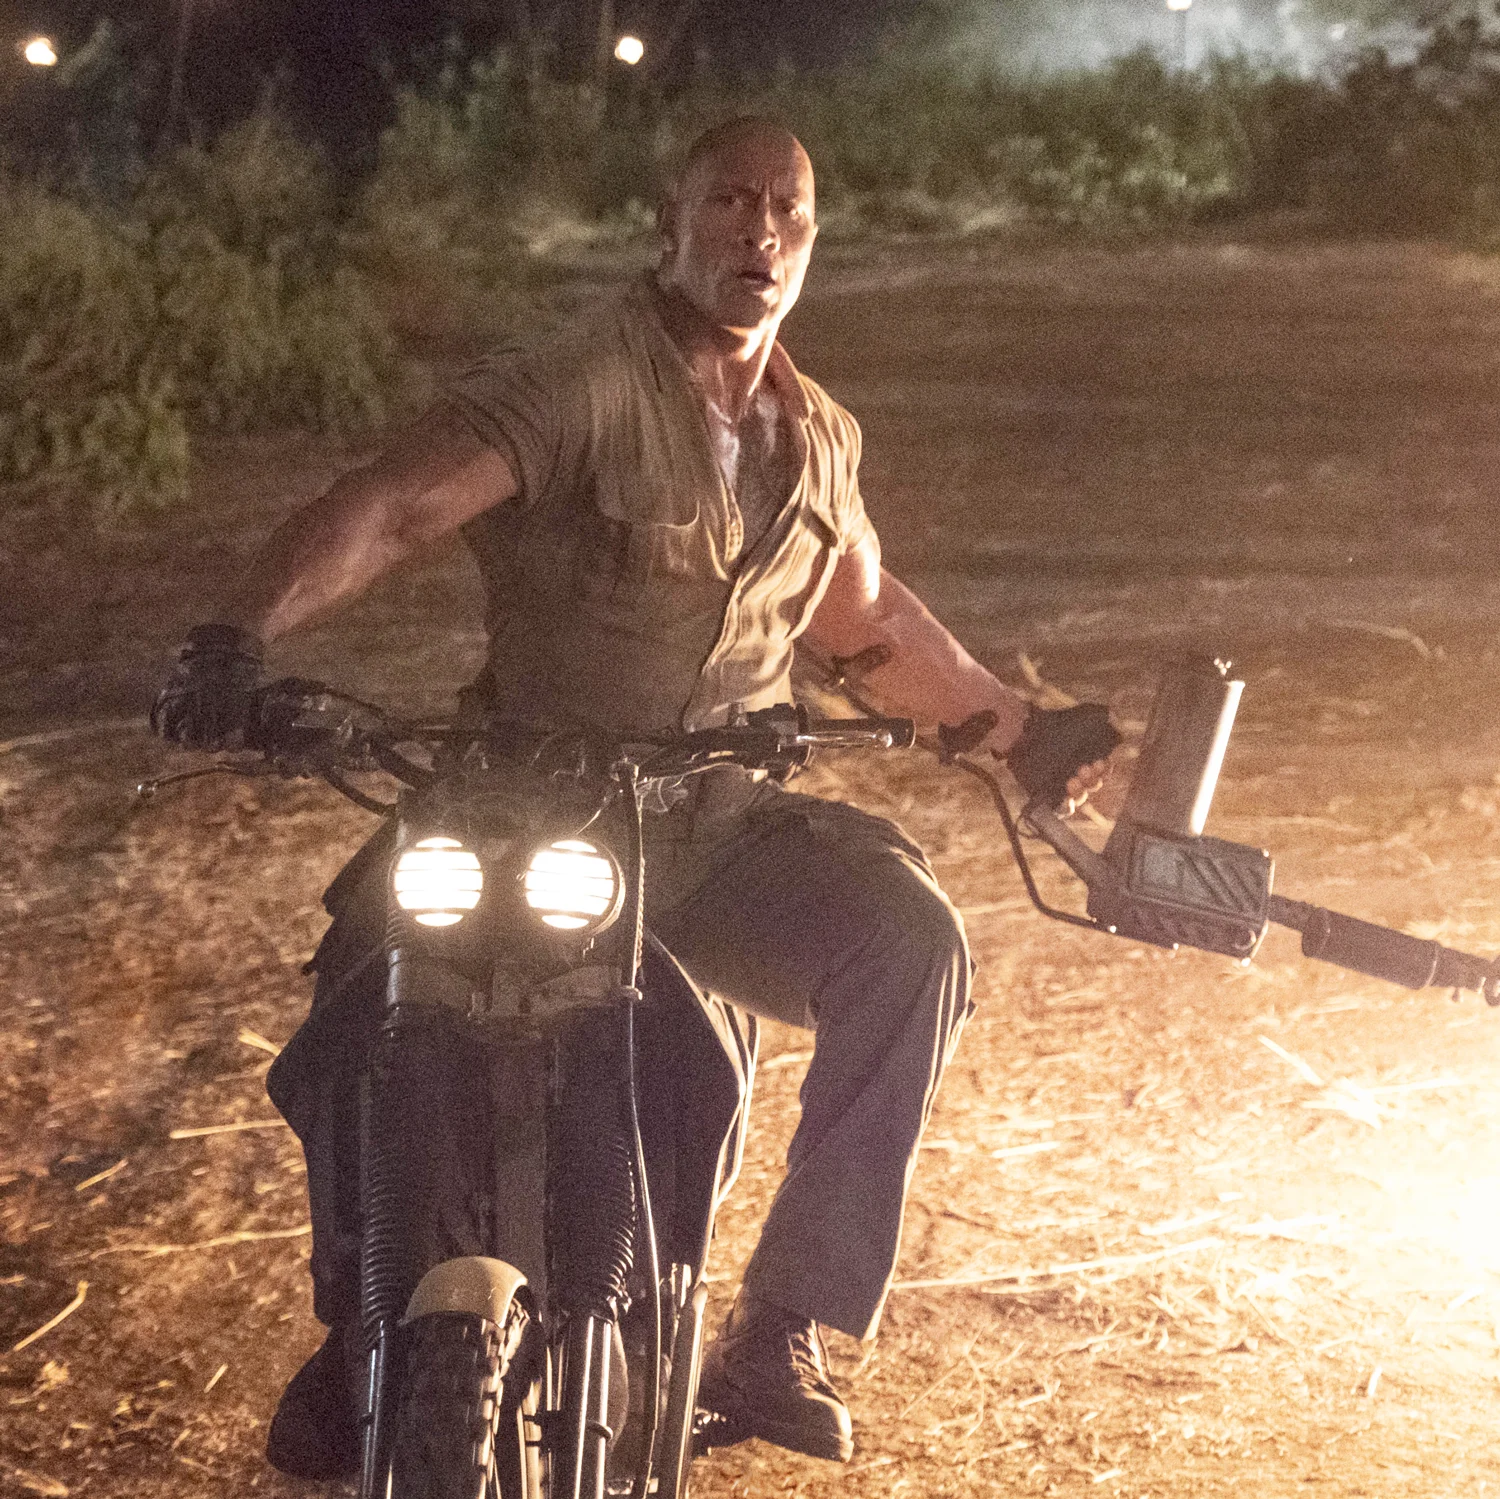Could you infer the character's mood or emotions from his expression and posture? The character's firm grip on the motorcycle's handlebars and his focused, intense gaze forward convey a strong sense of determination and readiness to confront whatever challenge lies ahead. His posture, leaning slightly forward, suggests active engagement and preparedness for action. 